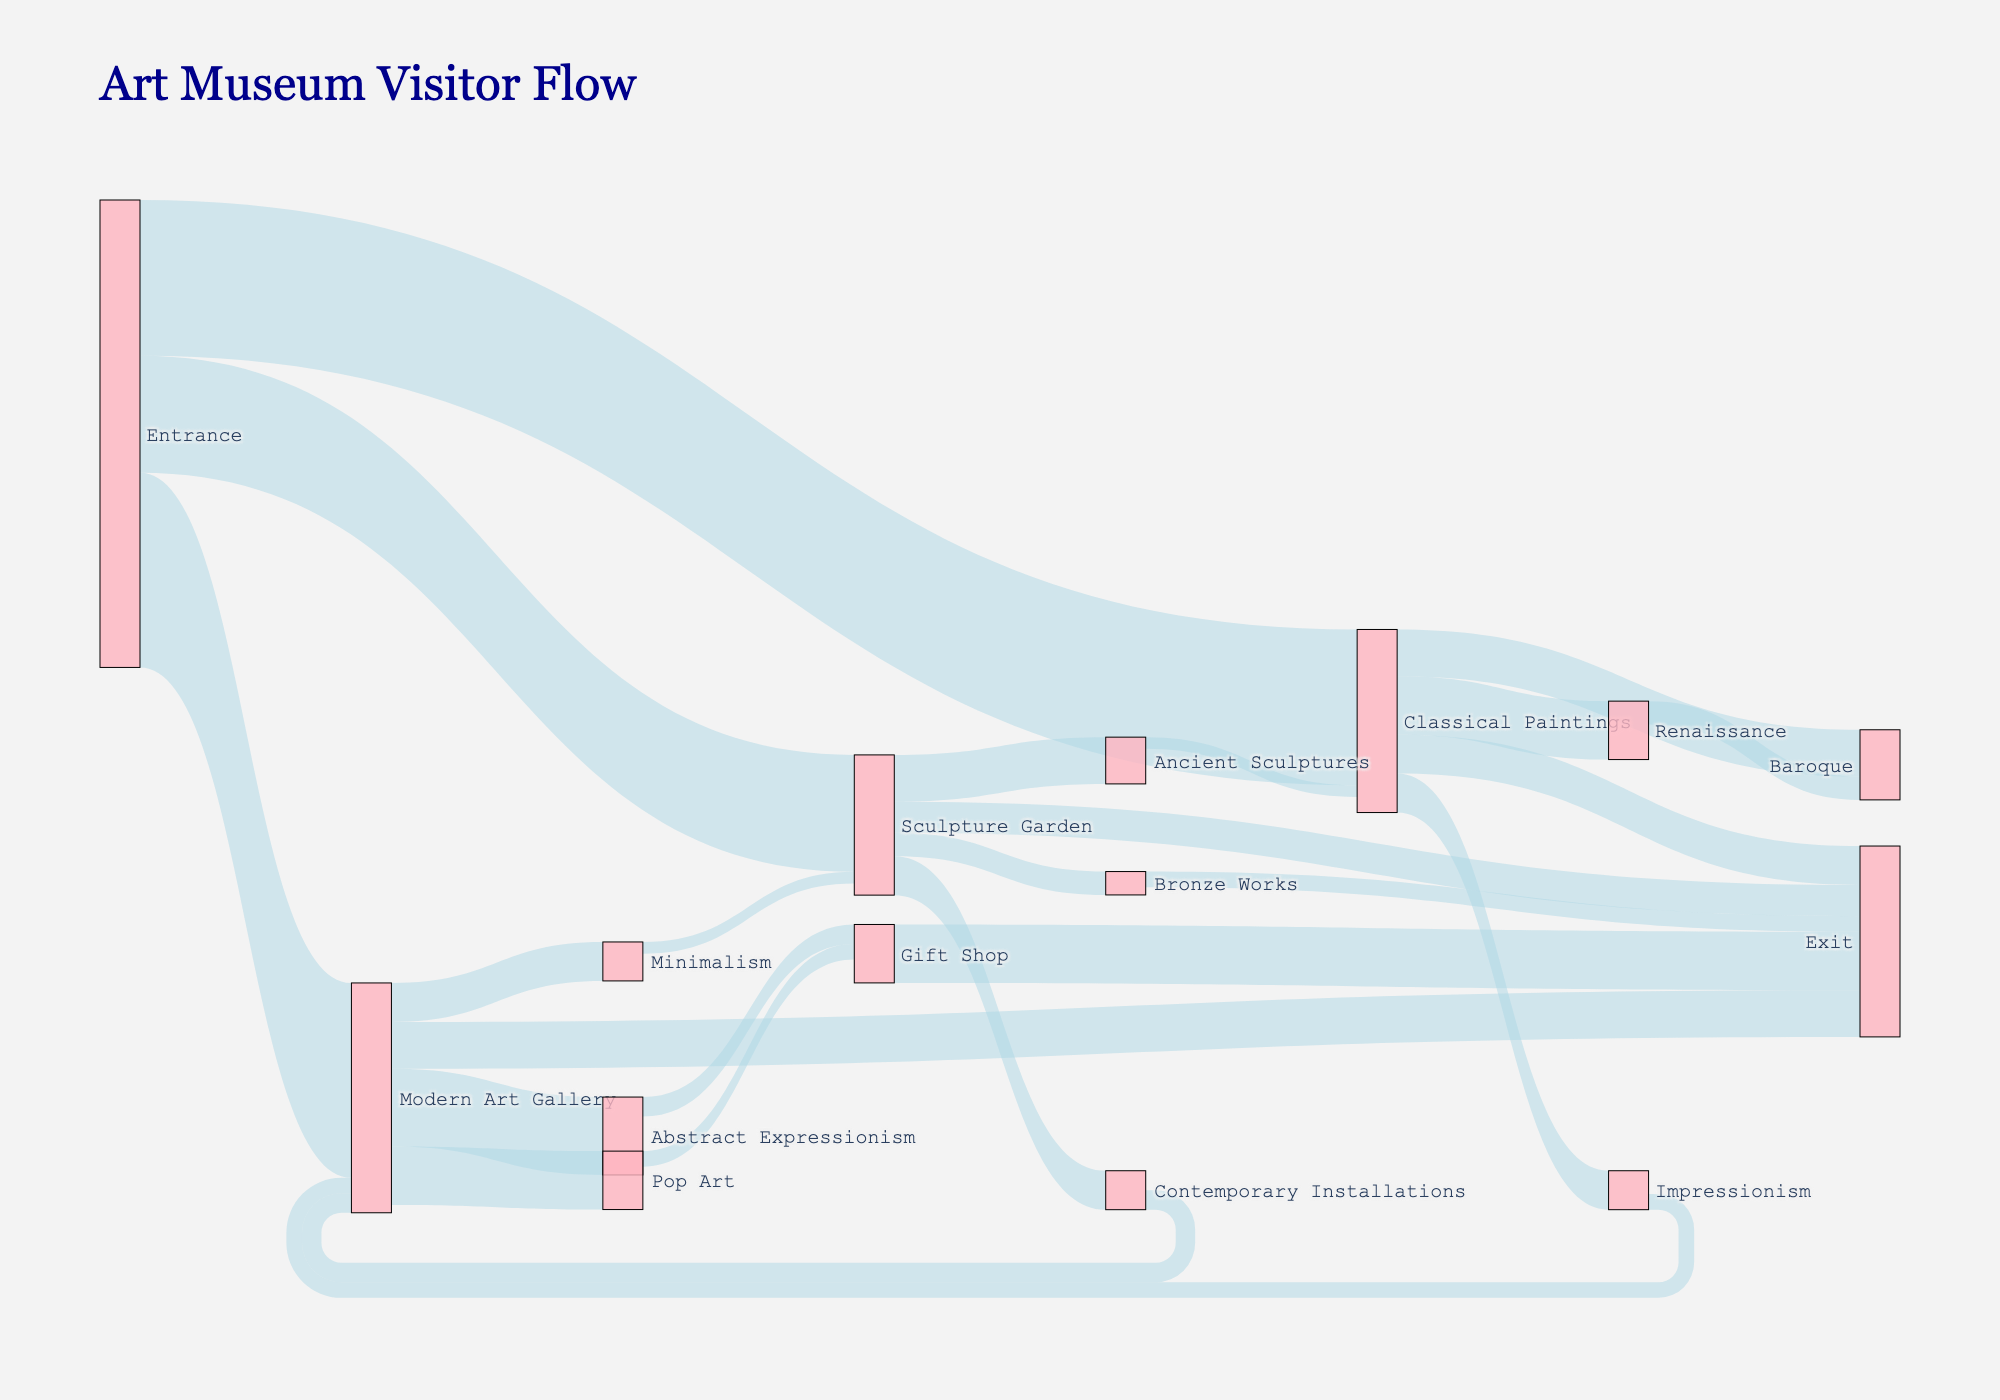How many visitors entered the Classical Paintings section from the entrance? The figure shows a flow from Entrance to Classical Paintings with an associated value. By looking at this link, we see it is labeled as 400.
Answer: 400 Which section received the highest number of visitors from the entrance? To find the section with the most visitors from the entrance, we compare the three values coming from the Entrance: Modern Art Gallery (500), Classical Paintings (400), Sculpture Garden (300). The highest value is Modern Art Gallery with 500 visitors.
Answer: Modern Art Gallery What is the most popular pathway starting from the Modern Art Gallery? From the Modern Art Gallery, there are paths leading to Abstract Expressionism (200), Pop Art (150), and Minimalism (100). The largest number of visitors moves to Abstract Expressionism.
Answer: Abstract Expressionism How many sections does the Sculpture Garden connect to directly? By observing the diagram, we see lines directed from Sculpture Garden to Ancient Sculptures, Contemporary Installations, and Bronze Works, totaling three sections.
Answer: 3 How many visitors left through the Exit directly from the Sculpture Garden? What about from the Gift Shop? Look for the flow lines ending at Exit from each section. The path from Sculpture Garden to Exit has 80 visitors and the path from Gift Shop to Exit has 150 visitors.
Answer: 80 from Sculpture Garden, 150 from Gift Shop Which section acts as an intermediary between Classical Paintings and the Exit? Follow the paths leading from Classical Paintings to its subsequent sections. There is a direct path to Exit, indicating Classical Paintings also serves as an intermediary. However, there is a notable intermediary path from Renaissance to Exit.
Answer: Renaissance What's the total number of visitors that passed through Modern Art Gallery including those from other sections? Visitors entered Modern Art Gallery from Entrance, Impressionism, and Contemporary Installations. Summing the values: Entrance (500), Impressionism (40), Contemporary Installations (50). Total is 500 + 40 + 50 = 590.
Answer: 590 How many visitors moved from Pop Art to the Gift Shop? Trace the line from Pop Art to Gift Shop, which has a label showing the value 40.
Answer: 40 What fraction of visitors moving to Modern Art Gallery from Classical Paintings later move to Pop Art? Observe the connection from Modern Art Gallery to Pop Art, which shows 150 visitors. Since 400 visitors enter Modern Art Gallery from Classical Paintings, the fraction is 150/400 = 3/8 or 0.375.
Answer: 0.375 How many visitors in total exited the museum? Follow the diagram to sum all the flows to Exit: Bronze Works (40), Gift Shop (150), Classical Paintings (100), Modern Art Gallery (120), Sculpture Garden (80). Total is 40 + 150 + 100 + 120 + 80 = 490.
Answer: 490 